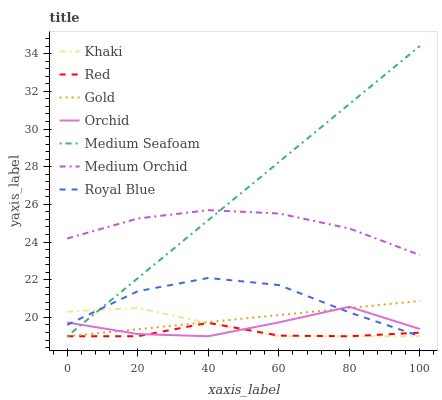Does Red have the minimum area under the curve?
Answer yes or no. Yes. Does Medium Seafoam have the maximum area under the curve?
Answer yes or no. Yes. Does Gold have the minimum area under the curve?
Answer yes or no. No. Does Gold have the maximum area under the curve?
Answer yes or no. No. Is Medium Seafoam the smoothest?
Answer yes or no. Yes. Is Orchid the roughest?
Answer yes or no. Yes. Is Gold the smoothest?
Answer yes or no. No. Is Gold the roughest?
Answer yes or no. No. Does Khaki have the lowest value?
Answer yes or no. Yes. Does Medium Orchid have the lowest value?
Answer yes or no. No. Does Medium Seafoam have the highest value?
Answer yes or no. Yes. Does Gold have the highest value?
Answer yes or no. No. Is Orchid less than Medium Orchid?
Answer yes or no. Yes. Is Medium Orchid greater than Orchid?
Answer yes or no. Yes. Does Red intersect Royal Blue?
Answer yes or no. Yes. Is Red less than Royal Blue?
Answer yes or no. No. Is Red greater than Royal Blue?
Answer yes or no. No. Does Orchid intersect Medium Orchid?
Answer yes or no. No. 